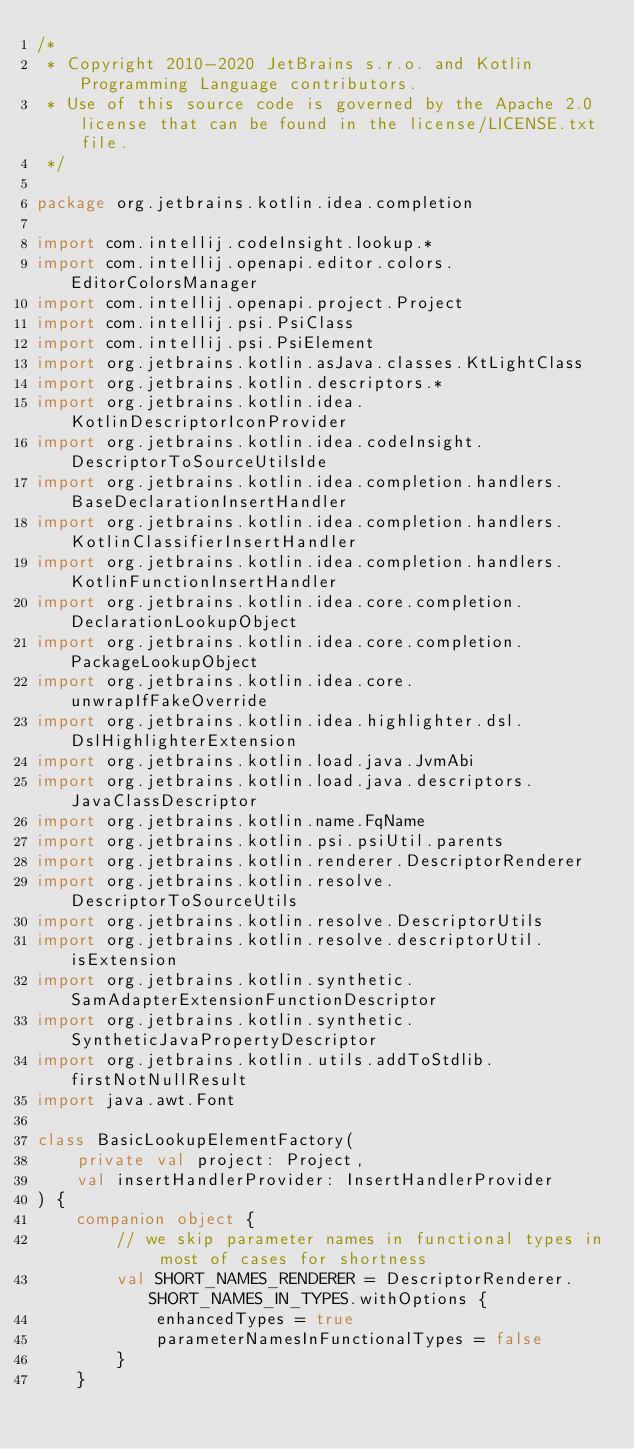<code> <loc_0><loc_0><loc_500><loc_500><_Kotlin_>/*
 * Copyright 2010-2020 JetBrains s.r.o. and Kotlin Programming Language contributors.
 * Use of this source code is governed by the Apache 2.0 license that can be found in the license/LICENSE.txt file.
 */

package org.jetbrains.kotlin.idea.completion

import com.intellij.codeInsight.lookup.*
import com.intellij.openapi.editor.colors.EditorColorsManager
import com.intellij.openapi.project.Project
import com.intellij.psi.PsiClass
import com.intellij.psi.PsiElement
import org.jetbrains.kotlin.asJava.classes.KtLightClass
import org.jetbrains.kotlin.descriptors.*
import org.jetbrains.kotlin.idea.KotlinDescriptorIconProvider
import org.jetbrains.kotlin.idea.codeInsight.DescriptorToSourceUtilsIde
import org.jetbrains.kotlin.idea.completion.handlers.BaseDeclarationInsertHandler
import org.jetbrains.kotlin.idea.completion.handlers.KotlinClassifierInsertHandler
import org.jetbrains.kotlin.idea.completion.handlers.KotlinFunctionInsertHandler
import org.jetbrains.kotlin.idea.core.completion.DeclarationLookupObject
import org.jetbrains.kotlin.idea.core.completion.PackageLookupObject
import org.jetbrains.kotlin.idea.core.unwrapIfFakeOverride
import org.jetbrains.kotlin.idea.highlighter.dsl.DslHighlighterExtension
import org.jetbrains.kotlin.load.java.JvmAbi
import org.jetbrains.kotlin.load.java.descriptors.JavaClassDescriptor
import org.jetbrains.kotlin.name.FqName
import org.jetbrains.kotlin.psi.psiUtil.parents
import org.jetbrains.kotlin.renderer.DescriptorRenderer
import org.jetbrains.kotlin.resolve.DescriptorToSourceUtils
import org.jetbrains.kotlin.resolve.DescriptorUtils
import org.jetbrains.kotlin.resolve.descriptorUtil.isExtension
import org.jetbrains.kotlin.synthetic.SamAdapterExtensionFunctionDescriptor
import org.jetbrains.kotlin.synthetic.SyntheticJavaPropertyDescriptor
import org.jetbrains.kotlin.utils.addToStdlib.firstNotNullResult
import java.awt.Font

class BasicLookupElementFactory(
    private val project: Project,
    val insertHandlerProvider: InsertHandlerProvider
) {
    companion object {
        // we skip parameter names in functional types in most of cases for shortness
        val SHORT_NAMES_RENDERER = DescriptorRenderer.SHORT_NAMES_IN_TYPES.withOptions {
            enhancedTypes = true
            parameterNamesInFunctionalTypes = false
        }
    }
</code> 